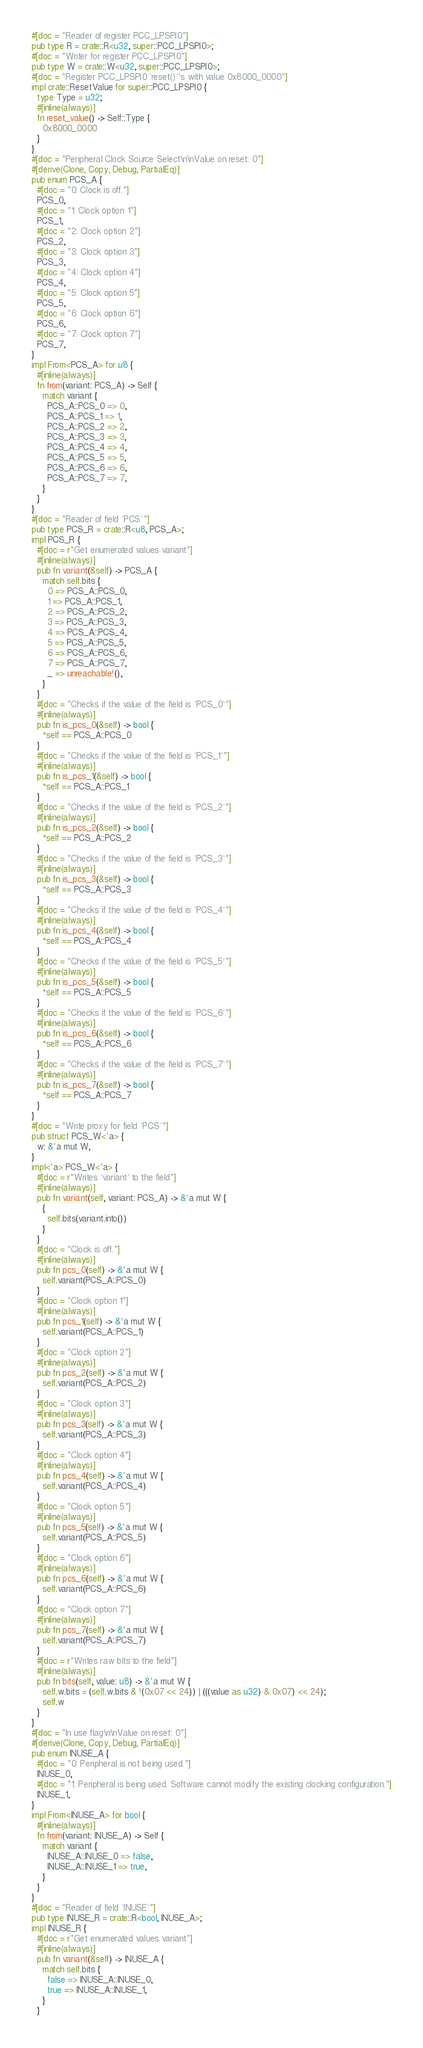Convert code to text. <code><loc_0><loc_0><loc_500><loc_500><_Rust_>#[doc = "Reader of register PCC_LPSPI0"]
pub type R = crate::R<u32, super::PCC_LPSPI0>;
#[doc = "Writer for register PCC_LPSPI0"]
pub type W = crate::W<u32, super::PCC_LPSPI0>;
#[doc = "Register PCC_LPSPI0 `reset()`'s with value 0x8000_0000"]
impl crate::ResetValue for super::PCC_LPSPI0 {
  type Type = u32;
  #[inline(always)]
  fn reset_value() -> Self::Type {
    0x8000_0000
  }
}
#[doc = "Peripheral Clock Source Select\n\nValue on reset: 0"]
#[derive(Clone, Copy, Debug, PartialEq)]
pub enum PCS_A {
  #[doc = "0: Clock is off."]
  PCS_0,
  #[doc = "1: Clock option 1"]
  PCS_1,
  #[doc = "2: Clock option 2"]
  PCS_2,
  #[doc = "3: Clock option 3"]
  PCS_3,
  #[doc = "4: Clock option 4"]
  PCS_4,
  #[doc = "5: Clock option 5"]
  PCS_5,
  #[doc = "6: Clock option 6"]
  PCS_6,
  #[doc = "7: Clock option 7"]
  PCS_7,
}
impl From<PCS_A> for u8 {
  #[inline(always)]
  fn from(variant: PCS_A) -> Self {
    match variant {
      PCS_A::PCS_0 => 0,
      PCS_A::PCS_1 => 1,
      PCS_A::PCS_2 => 2,
      PCS_A::PCS_3 => 3,
      PCS_A::PCS_4 => 4,
      PCS_A::PCS_5 => 5,
      PCS_A::PCS_6 => 6,
      PCS_A::PCS_7 => 7,
    }
  }
}
#[doc = "Reader of field `PCS`"]
pub type PCS_R = crate::R<u8, PCS_A>;
impl PCS_R {
  #[doc = r"Get enumerated values variant"]
  #[inline(always)]
  pub fn variant(&self) -> PCS_A {
    match self.bits {
      0 => PCS_A::PCS_0,
      1 => PCS_A::PCS_1,
      2 => PCS_A::PCS_2,
      3 => PCS_A::PCS_3,
      4 => PCS_A::PCS_4,
      5 => PCS_A::PCS_5,
      6 => PCS_A::PCS_6,
      7 => PCS_A::PCS_7,
      _ => unreachable!(),
    }
  }
  #[doc = "Checks if the value of the field is `PCS_0`"]
  #[inline(always)]
  pub fn is_pcs_0(&self) -> bool {
    *self == PCS_A::PCS_0
  }
  #[doc = "Checks if the value of the field is `PCS_1`"]
  #[inline(always)]
  pub fn is_pcs_1(&self) -> bool {
    *self == PCS_A::PCS_1
  }
  #[doc = "Checks if the value of the field is `PCS_2`"]
  #[inline(always)]
  pub fn is_pcs_2(&self) -> bool {
    *self == PCS_A::PCS_2
  }
  #[doc = "Checks if the value of the field is `PCS_3`"]
  #[inline(always)]
  pub fn is_pcs_3(&self) -> bool {
    *self == PCS_A::PCS_3
  }
  #[doc = "Checks if the value of the field is `PCS_4`"]
  #[inline(always)]
  pub fn is_pcs_4(&self) -> bool {
    *self == PCS_A::PCS_4
  }
  #[doc = "Checks if the value of the field is `PCS_5`"]
  #[inline(always)]
  pub fn is_pcs_5(&self) -> bool {
    *self == PCS_A::PCS_5
  }
  #[doc = "Checks if the value of the field is `PCS_6`"]
  #[inline(always)]
  pub fn is_pcs_6(&self) -> bool {
    *self == PCS_A::PCS_6
  }
  #[doc = "Checks if the value of the field is `PCS_7`"]
  #[inline(always)]
  pub fn is_pcs_7(&self) -> bool {
    *self == PCS_A::PCS_7
  }
}
#[doc = "Write proxy for field `PCS`"]
pub struct PCS_W<'a> {
  w: &'a mut W,
}
impl<'a> PCS_W<'a> {
  #[doc = r"Writes `variant` to the field"]
  #[inline(always)]
  pub fn variant(self, variant: PCS_A) -> &'a mut W {
    {
      self.bits(variant.into())
    }
  }
  #[doc = "Clock is off."]
  #[inline(always)]
  pub fn pcs_0(self) -> &'a mut W {
    self.variant(PCS_A::PCS_0)
  }
  #[doc = "Clock option 1"]
  #[inline(always)]
  pub fn pcs_1(self) -> &'a mut W {
    self.variant(PCS_A::PCS_1)
  }
  #[doc = "Clock option 2"]
  #[inline(always)]
  pub fn pcs_2(self) -> &'a mut W {
    self.variant(PCS_A::PCS_2)
  }
  #[doc = "Clock option 3"]
  #[inline(always)]
  pub fn pcs_3(self) -> &'a mut W {
    self.variant(PCS_A::PCS_3)
  }
  #[doc = "Clock option 4"]
  #[inline(always)]
  pub fn pcs_4(self) -> &'a mut W {
    self.variant(PCS_A::PCS_4)
  }
  #[doc = "Clock option 5"]
  #[inline(always)]
  pub fn pcs_5(self) -> &'a mut W {
    self.variant(PCS_A::PCS_5)
  }
  #[doc = "Clock option 6"]
  #[inline(always)]
  pub fn pcs_6(self) -> &'a mut W {
    self.variant(PCS_A::PCS_6)
  }
  #[doc = "Clock option 7"]
  #[inline(always)]
  pub fn pcs_7(self) -> &'a mut W {
    self.variant(PCS_A::PCS_7)
  }
  #[doc = r"Writes raw bits to the field"]
  #[inline(always)]
  pub fn bits(self, value: u8) -> &'a mut W {
    self.w.bits = (self.w.bits & !(0x07 << 24)) | (((value as u32) & 0x07) << 24);
    self.w
  }
}
#[doc = "In use flag\n\nValue on reset: 0"]
#[derive(Clone, Copy, Debug, PartialEq)]
pub enum INUSE_A {
  #[doc = "0: Peripheral is not being used."]
  INUSE_0,
  #[doc = "1: Peripheral is being used. Software cannot modify the existing clocking configuration."]
  INUSE_1,
}
impl From<INUSE_A> for bool {
  #[inline(always)]
  fn from(variant: INUSE_A) -> Self {
    match variant {
      INUSE_A::INUSE_0 => false,
      INUSE_A::INUSE_1 => true,
    }
  }
}
#[doc = "Reader of field `INUSE`"]
pub type INUSE_R = crate::R<bool, INUSE_A>;
impl INUSE_R {
  #[doc = r"Get enumerated values variant"]
  #[inline(always)]
  pub fn variant(&self) -> INUSE_A {
    match self.bits {
      false => INUSE_A::INUSE_0,
      true => INUSE_A::INUSE_1,
    }
  }</code> 